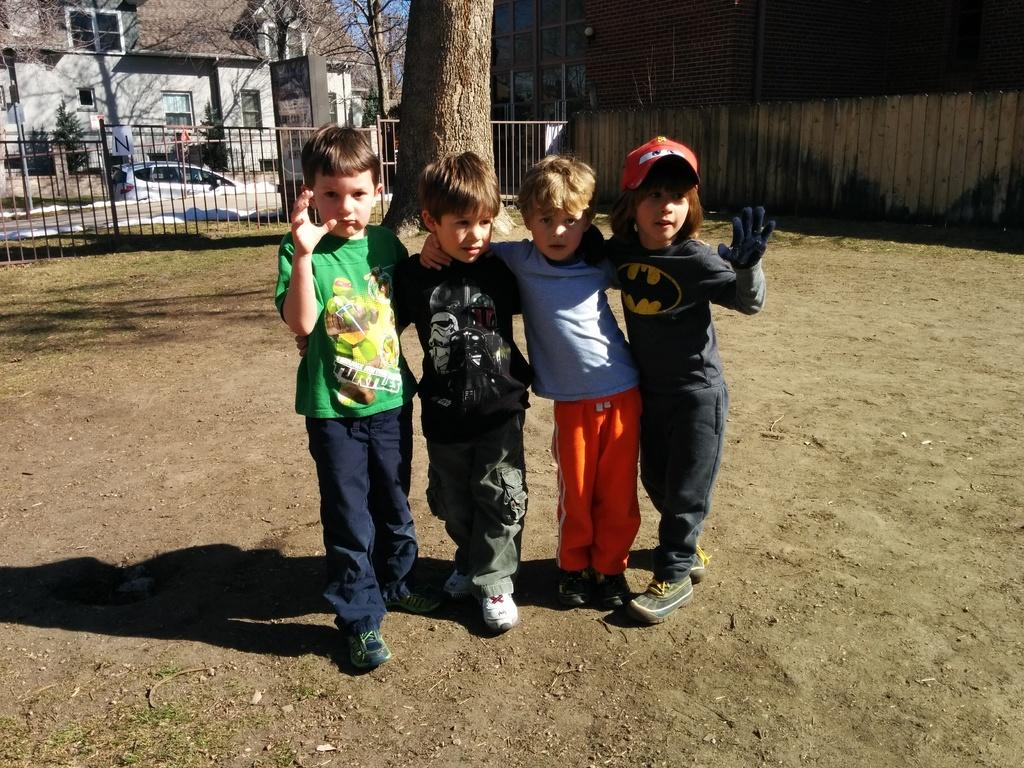How many children are in the image? There are four children standing on the ground in the image. What can be seen in the background of the image? In the background of the image, there is grass, a fence, trees, a car, plants, windows, and the sky. What type of surface are the children standing on? The children are standing on the ground. What type of sugar is being used for the children's education in the image? There is no sugar or education-related activity present in the image. 